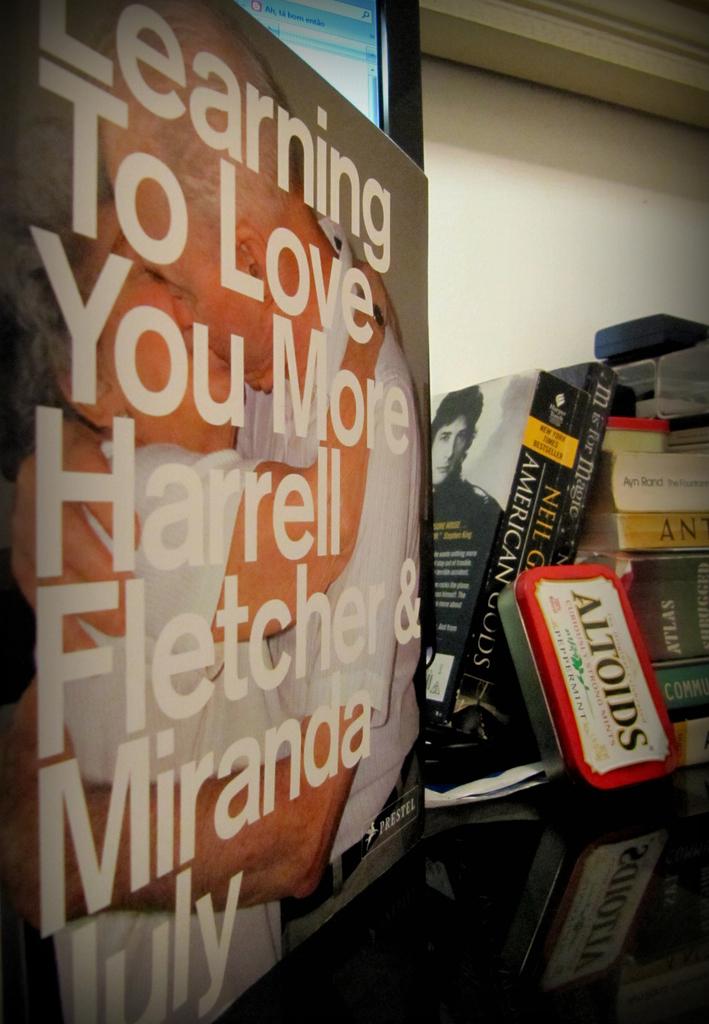What does the tin contain?
Ensure brevity in your answer.  Altoids. What is the title of the book behind the container with the inscription altoids?
Offer a very short reply. American gods. 